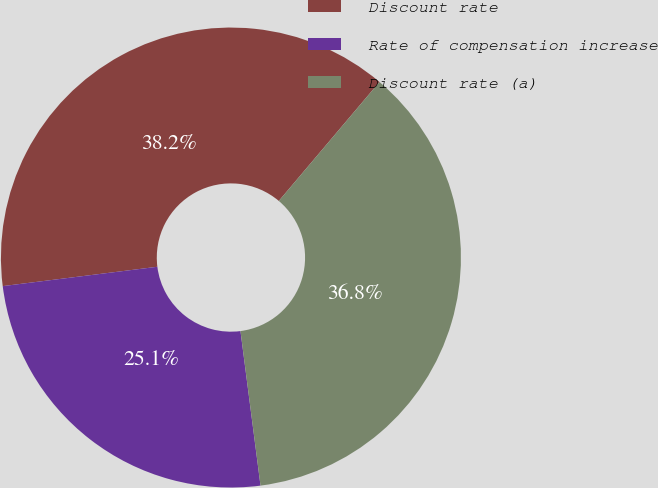<chart> <loc_0><loc_0><loc_500><loc_500><pie_chart><fcel>Discount rate<fcel>Rate of compensation increase<fcel>Discount rate (a)<nl><fcel>38.16%<fcel>25.07%<fcel>36.77%<nl></chart> 